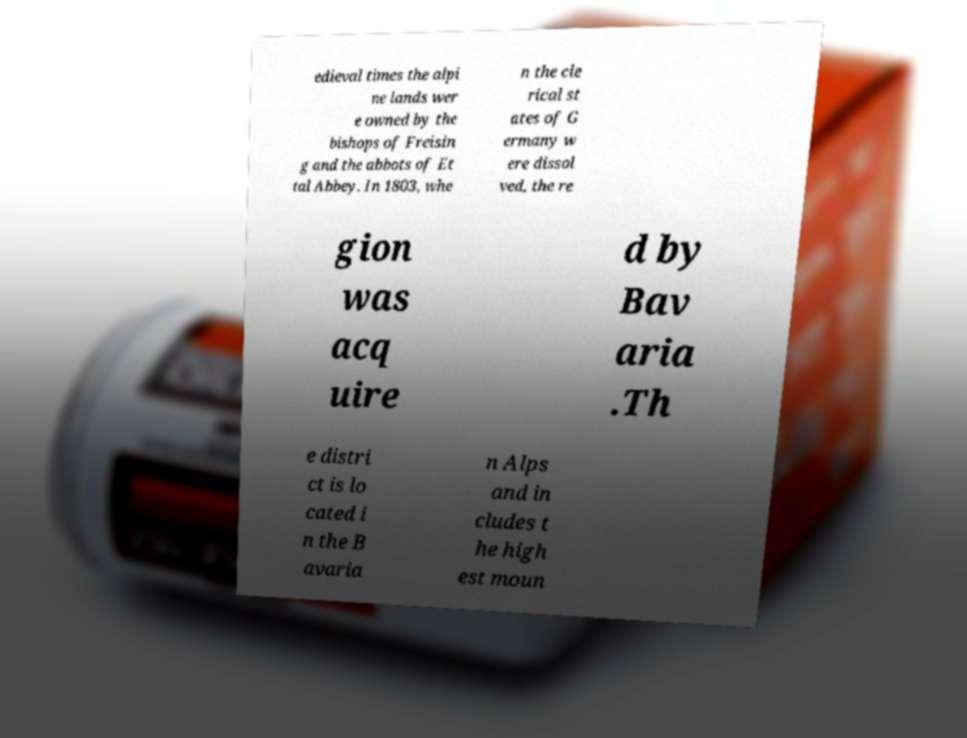Could you assist in decoding the text presented in this image and type it out clearly? edieval times the alpi ne lands wer e owned by the bishops of Freisin g and the abbots of Et tal Abbey. In 1803, whe n the cle rical st ates of G ermany w ere dissol ved, the re gion was acq uire d by Bav aria .Th e distri ct is lo cated i n the B avaria n Alps and in cludes t he high est moun 